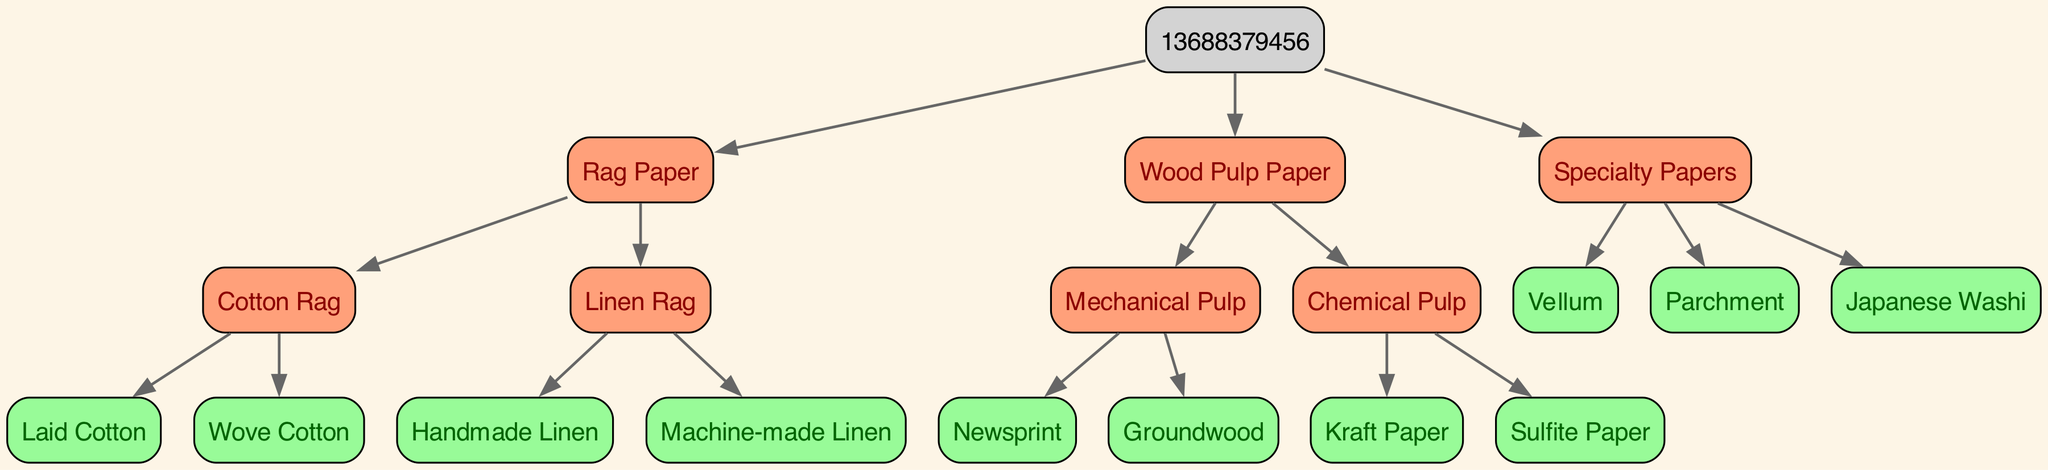What is the root of the family tree? The root node in the family tree represents the main category from which all other paper types stem. In this diagram, the root is labeled as "Vintage Journal Paper."
Answer: Vintage Journal Paper How many main branches are there in the family tree? The main branches represent the highest-level categories of paper types directly under the root node. In the diagram, there are three main branches: Rag Paper, Wood Pulp Paper, and Specialty Papers.
Answer: 3 What type of paper is "Kraft Paper"? "Kraft Paper" falls under the category of Chemical Pulp, which is one of the subcategories under Wood Pulp Paper. Following the relationship from the root through its two levels of children, this can be identified clearly.
Answer: Chemical Pulp Name one type of paper that is made from cotton. The paper types made from cotton are classified under Rag Paper. The diagram shows that "Cotton Rag" is a subtype within Rag Paper, which confirms this.
Answer: Cotton Rag What are the two types of linen rag paper mentioned? The children of the Linen Rag node indicate the specific kinds of linen paper types available. The diagram lists "Handmade Linen" and "Machine-made Linen" as the two types within the Linen Rag category.
Answer: Handmade Linen, Machine-made Linen Which paper type is associated with "Groundwood"? "Groundwood" is associated with the Mechanical Pulp category found under Wood Pulp Paper. By tracing the edges, we see that it is listed directly under the Mechanical Pulp branch.
Answer: Mechanical Pulp Which paper type has the least number of subtypes? To determine this, we can analyze each main branch and count the number of children for each. "Specialty Papers" has three types (Vellum, Parchment, Japanese Washi), while "Rag Paper" has four, and "Wood Pulp Paper" has four; thus, Specialty Papers has the least.
Answer: Specialty Papers What is the connection between "Laid Cotton" and "Wove Cotton"? "Laid Cotton" and "Wove Cotton" are both children of the Cotton Rag node. This indicates that they share a direct sibling relationship under the Rag Paper category, both originating from the same parent.
Answer: Cotton Rag Name one type of specialty paper. "Specialty Papers" has multiple types listed as its children in the diagram, and any one of those—such as "Vellum"—can be identified as an example of a specialty paper type.
Answer: Vellum 